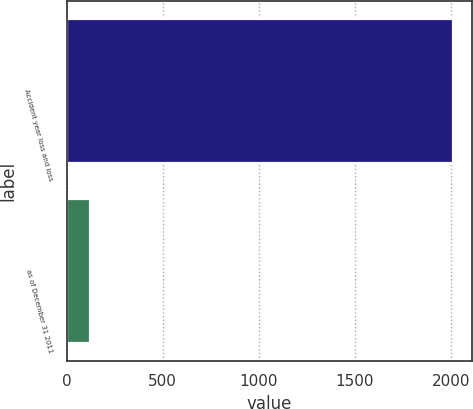Convert chart to OTSL. <chart><loc_0><loc_0><loc_500><loc_500><bar_chart><fcel>Accident year loss and loss<fcel>as of December 31 2011<nl><fcel>2011<fcel>122.7<nl></chart> 